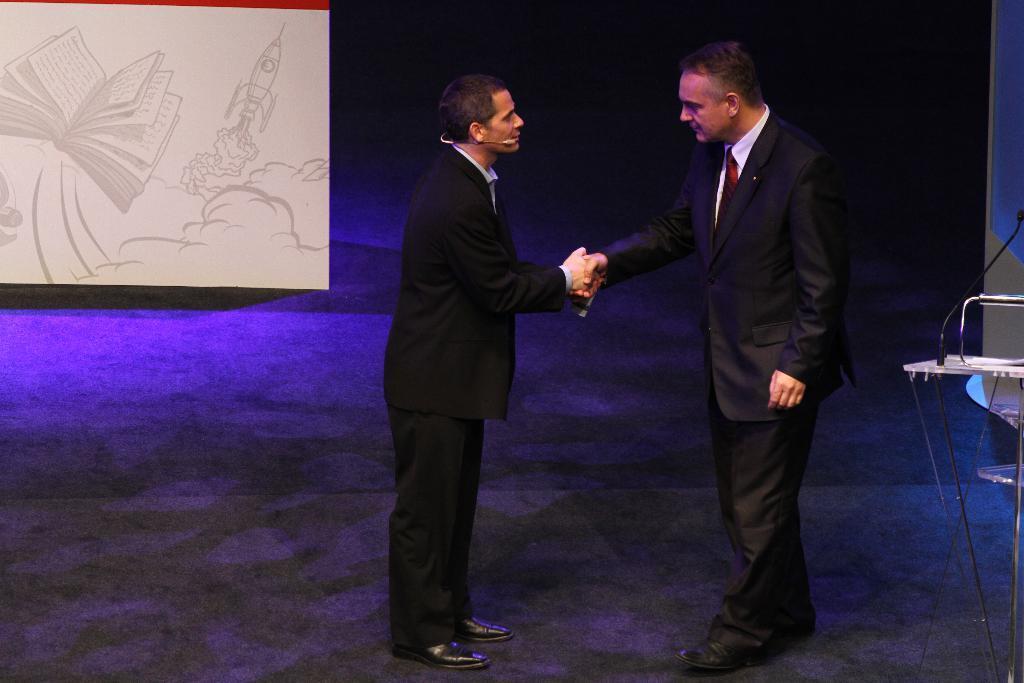In one or two sentences, can you explain what this image depicts? This image consists of two persons wearing black suits. At the bottom, there is a floor. On the left, we can see a board on which it looks like a drawing. The background is too dark. On the right, it looks like a stand. 